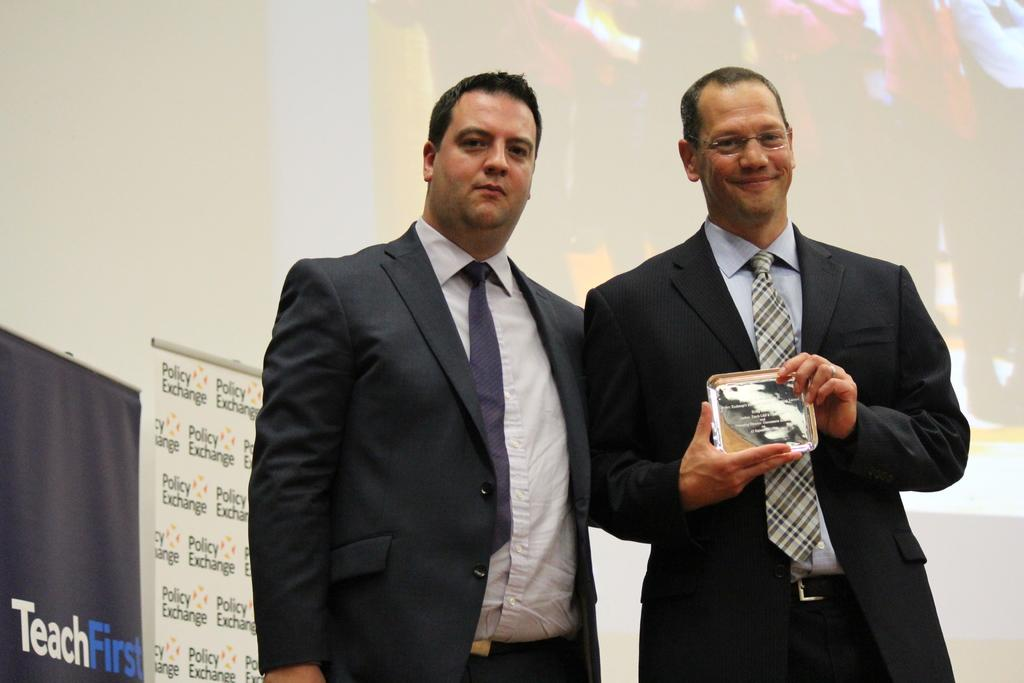How many people are present in the image? There are two persons standing in the image. What is the facial expression of one of the persons? One person is smiling. What is the smiling person holding? The smiling person is holding an object. What can be seen hanging in the image? There are banners in the image. What is visible in the background of the image? There is a screen in the background of the image. What type of thunder can be heard in the image? There is no thunder present in the image; it is a still image with no sound. How many sacks are visible in the image? There are no sacks present in the image. 